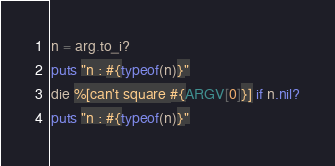Convert code to text. <code><loc_0><loc_0><loc_500><loc_500><_Crystal_>n = arg.to_i?
puts "n : #{typeof(n)}"
die %[can't square #{ARGV[0]}] if n.nil?
puts "n : #{typeof(n)}"</code> 